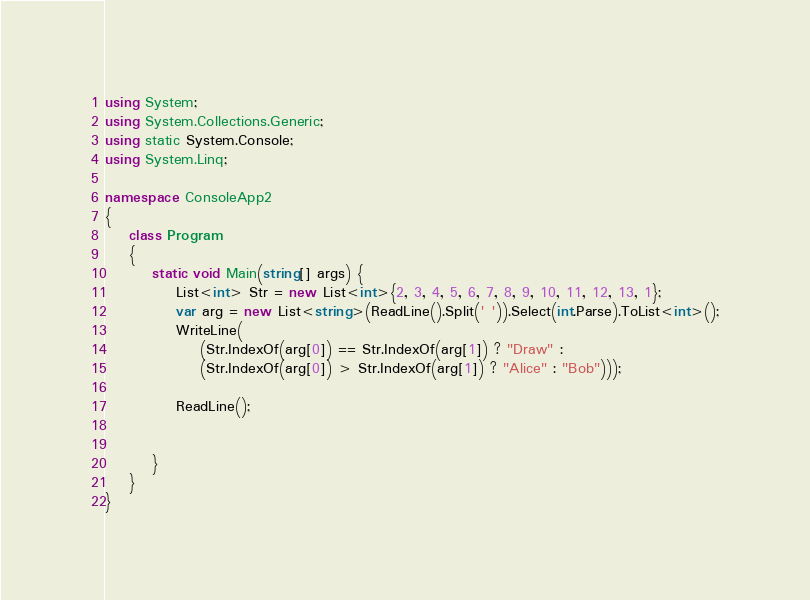<code> <loc_0><loc_0><loc_500><loc_500><_C#_>using System;
using System.Collections.Generic;
using static System.Console;
using System.Linq;

namespace ConsoleApp2
{
    class Program
    {
        static void Main(string[] args) {
            List<int> Str = new List<int>{2, 3, 4, 5, 6, 7, 8, 9, 10, 11, 12, 13, 1};
            var arg = new List<string>(ReadLine().Split(' ')).Select(int.Parse).ToList<int>();
            WriteLine(
                (Str.IndexOf(arg[0]) == Str.IndexOf(arg[1]) ? "Draw" :
                (Str.IndexOf(arg[0]) > Str.IndexOf(arg[1]) ? "Alice" : "Bob")));

            ReadLine();


        }
    }
}
</code> 